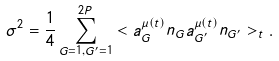Convert formula to latex. <formula><loc_0><loc_0><loc_500><loc_500>\sigma ^ { 2 } = \frac { 1 } { 4 } \sum ^ { 2 P } _ { G = 1 , G ^ { \prime } = 1 } < a _ { G } ^ { \mu ( t ) } n _ { G } a _ { G ^ { \prime } } ^ { \mu ( t ) } n _ { G ^ { \prime } } > _ { t } .</formula> 